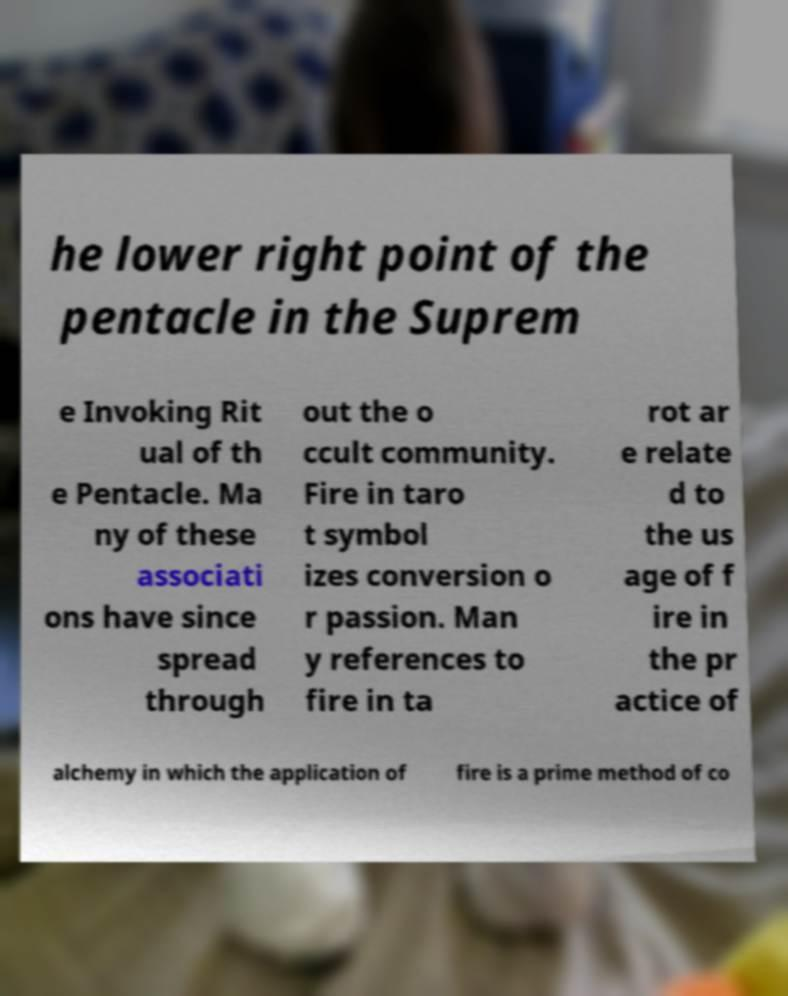I need the written content from this picture converted into text. Can you do that? he lower right point of the pentacle in the Suprem e Invoking Rit ual of th e Pentacle. Ma ny of these associati ons have since spread through out the o ccult community. Fire in taro t symbol izes conversion o r passion. Man y references to fire in ta rot ar e relate d to the us age of f ire in the pr actice of alchemy in which the application of fire is a prime method of co 